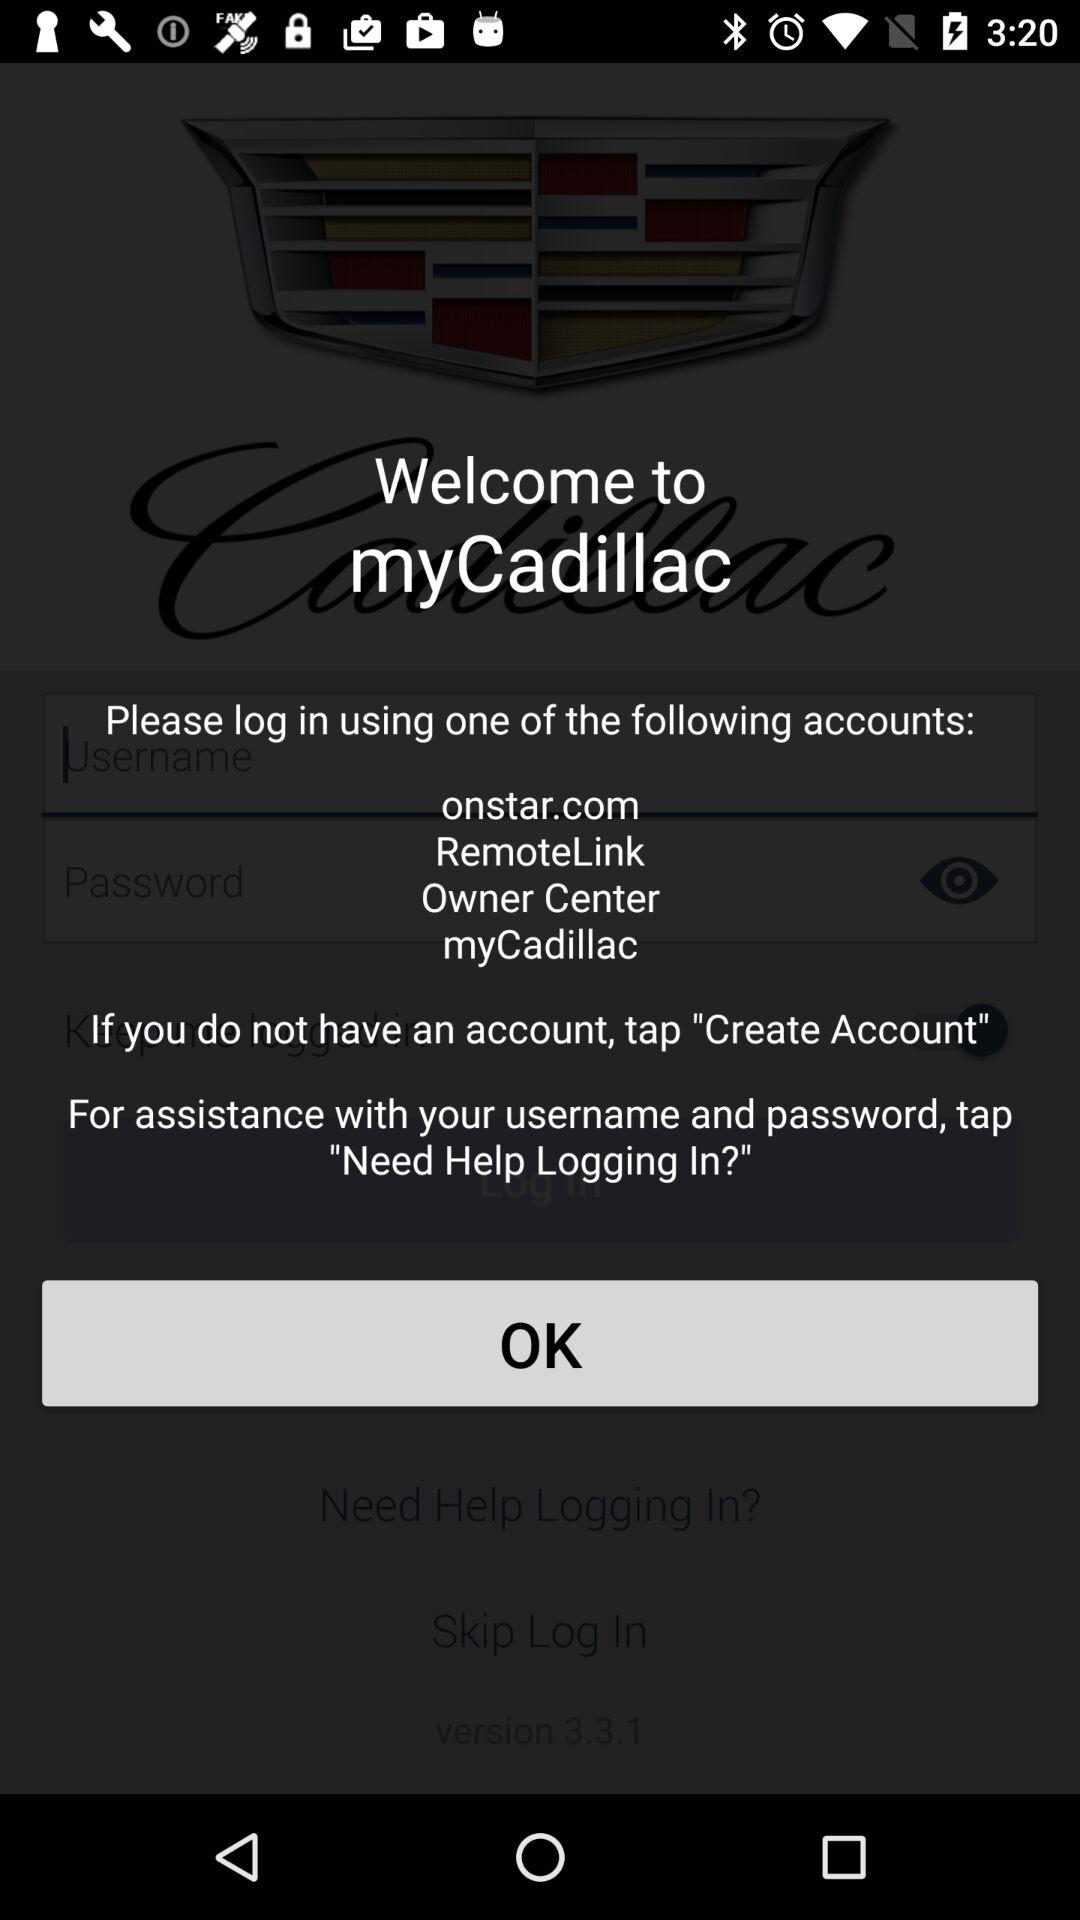How many text inputs are on the screen?
Answer the question using a single word or phrase. 2 